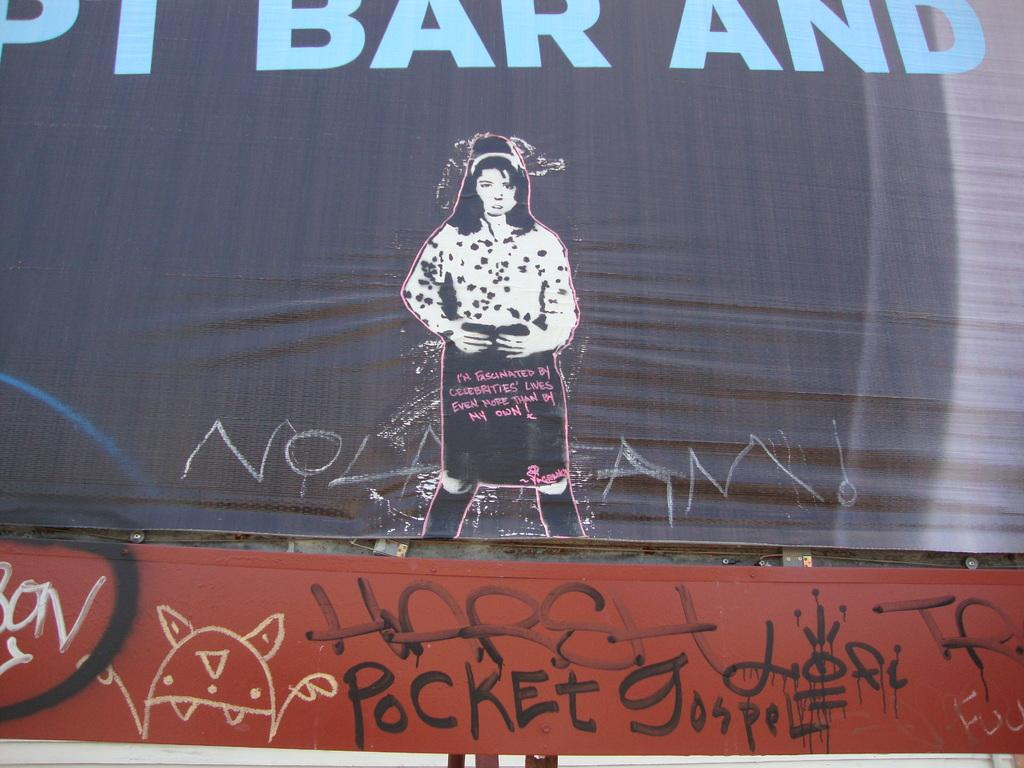What is present in the image that is used for displaying information or messages? The image contains banners. Who is the main subject in the image? There is a woman in the center of the image. Where can text be found in the image? Text can be found at the top and bottom of the image. Can you tell me how many deer are visible in the image? There are no deer present in the image. What organization is responsible for the event depicted in the image? The provided facts do not mention any organization or event, so it cannot be determined from the image. 